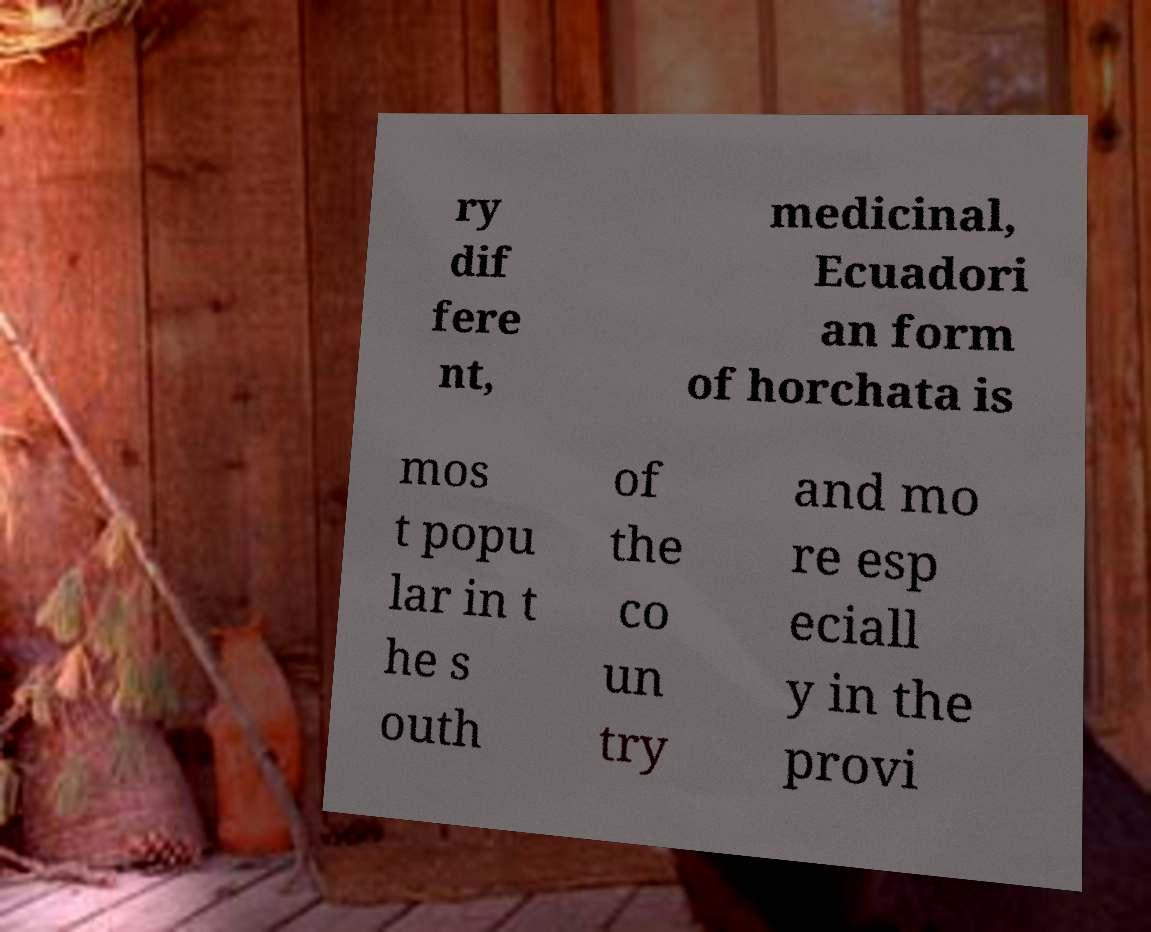There's text embedded in this image that I need extracted. Can you transcribe it verbatim? ry dif fere nt, medicinal, Ecuadori an form of horchata is mos t popu lar in t he s outh of the co un try and mo re esp eciall y in the provi 